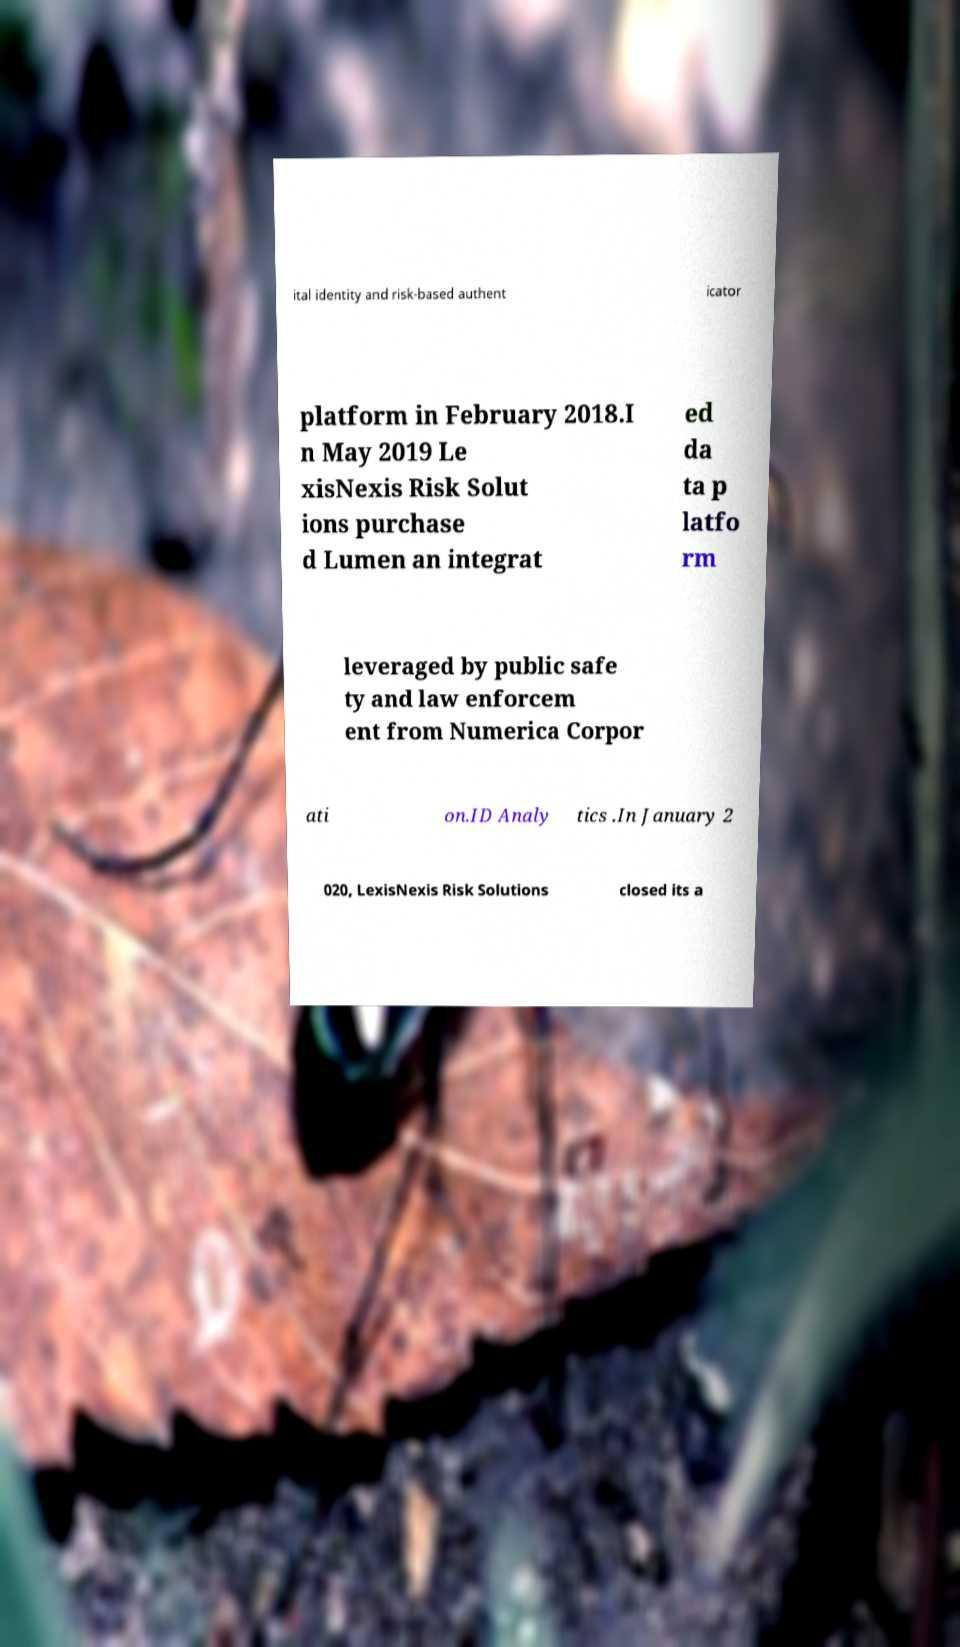For documentation purposes, I need the text within this image transcribed. Could you provide that? ital identity and risk-based authent icator platform in February 2018.I n May 2019 Le xisNexis Risk Solut ions purchase d Lumen an integrat ed da ta p latfo rm leveraged by public safe ty and law enforcem ent from Numerica Corpor ati on.ID Analy tics .In January 2 020, LexisNexis Risk Solutions closed its a 